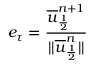<formula> <loc_0><loc_0><loc_500><loc_500>e _ { \tau } = \frac { \overline { u } _ { \frac { 1 } { 2 } } ^ { n + 1 } } { | | \overline { u } _ { \frac { 1 } { 2 } } ^ { n } | | }</formula> 